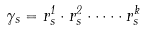Convert formula to latex. <formula><loc_0><loc_0><loc_500><loc_500>\gamma _ { s } = r ^ { 1 } _ { s } \cdot r ^ { 2 } _ { s } \cdot \dots \cdot r ^ { k } _ { s }</formula> 